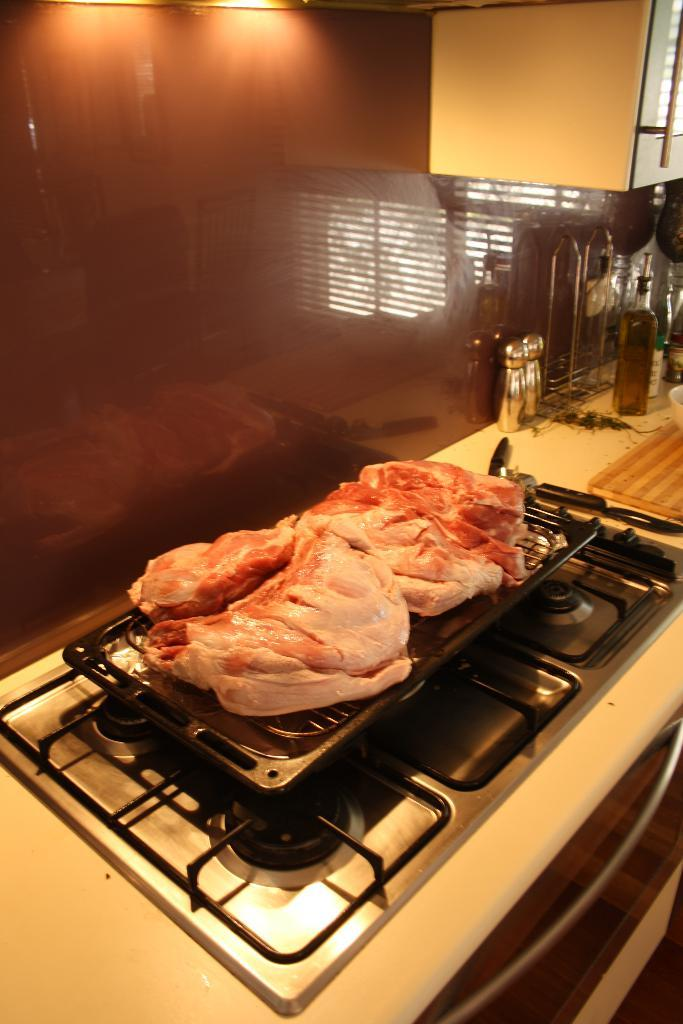What is being cooked on the stove in the image? Meat is being cooked on a stove in the image. What else can be seen in the image besides the stove? There are bottles on a table in the image. Where is the rest of the lunchroom located in the image? There is no mention of a lunchroom in the image, so it cannot be determined where the rest of it might be located. 